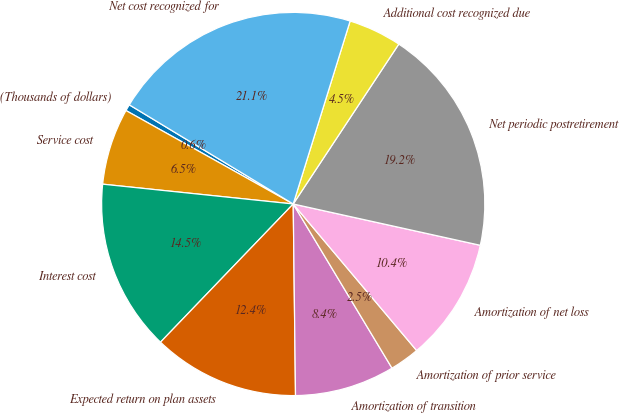<chart> <loc_0><loc_0><loc_500><loc_500><pie_chart><fcel>(Thousands of dollars)<fcel>Service cost<fcel>Interest cost<fcel>Expected return on plan assets<fcel>Amortization of transition<fcel>Amortization of prior service<fcel>Amortization of net loss<fcel>Net periodic postretirement<fcel>Additional cost recognized due<fcel>Net cost recognized for<nl><fcel>0.55%<fcel>6.46%<fcel>14.47%<fcel>12.37%<fcel>8.43%<fcel>2.52%<fcel>10.4%<fcel>19.17%<fcel>4.49%<fcel>21.14%<nl></chart> 